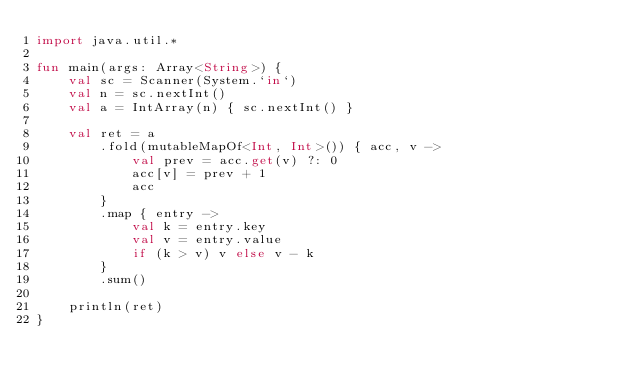Convert code to text. <code><loc_0><loc_0><loc_500><loc_500><_Kotlin_>import java.util.*

fun main(args: Array<String>) {
    val sc = Scanner(System.`in`)
    val n = sc.nextInt()
    val a = IntArray(n) { sc.nextInt() }

    val ret = a
        .fold(mutableMapOf<Int, Int>()) { acc, v ->
            val prev = acc.get(v) ?: 0
            acc[v] = prev + 1
            acc
        }
        .map { entry ->
            val k = entry.key
            val v = entry.value
            if (k > v) v else v - k
        }
        .sum()

    println(ret)
}</code> 